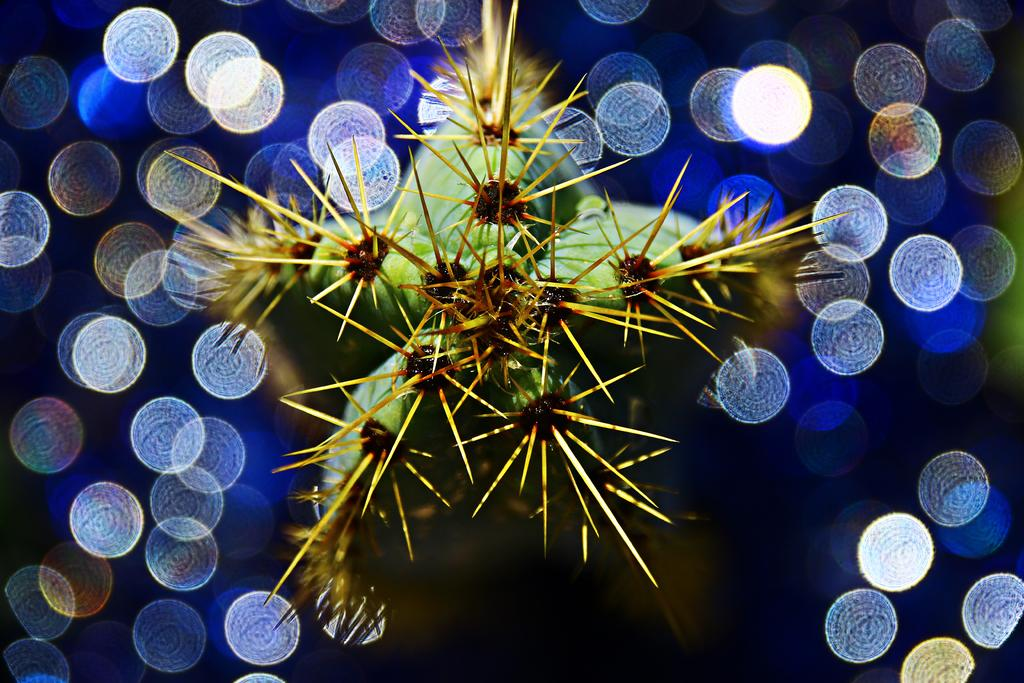What can be observed about the image's appearance? The image appears to be edited. What is the main subject in the middle of the image? There is a plant in the middle of the image. What is the purpose of the light focuses around the plant? The light focuses around the plant are likely used to highlight or emphasize the plant in the image. How does the plant's wealth contribute to the image's composition? There is no mention of the plant's wealth in the image or the provided facts, so it cannot be determined how it contributes to the composition. 